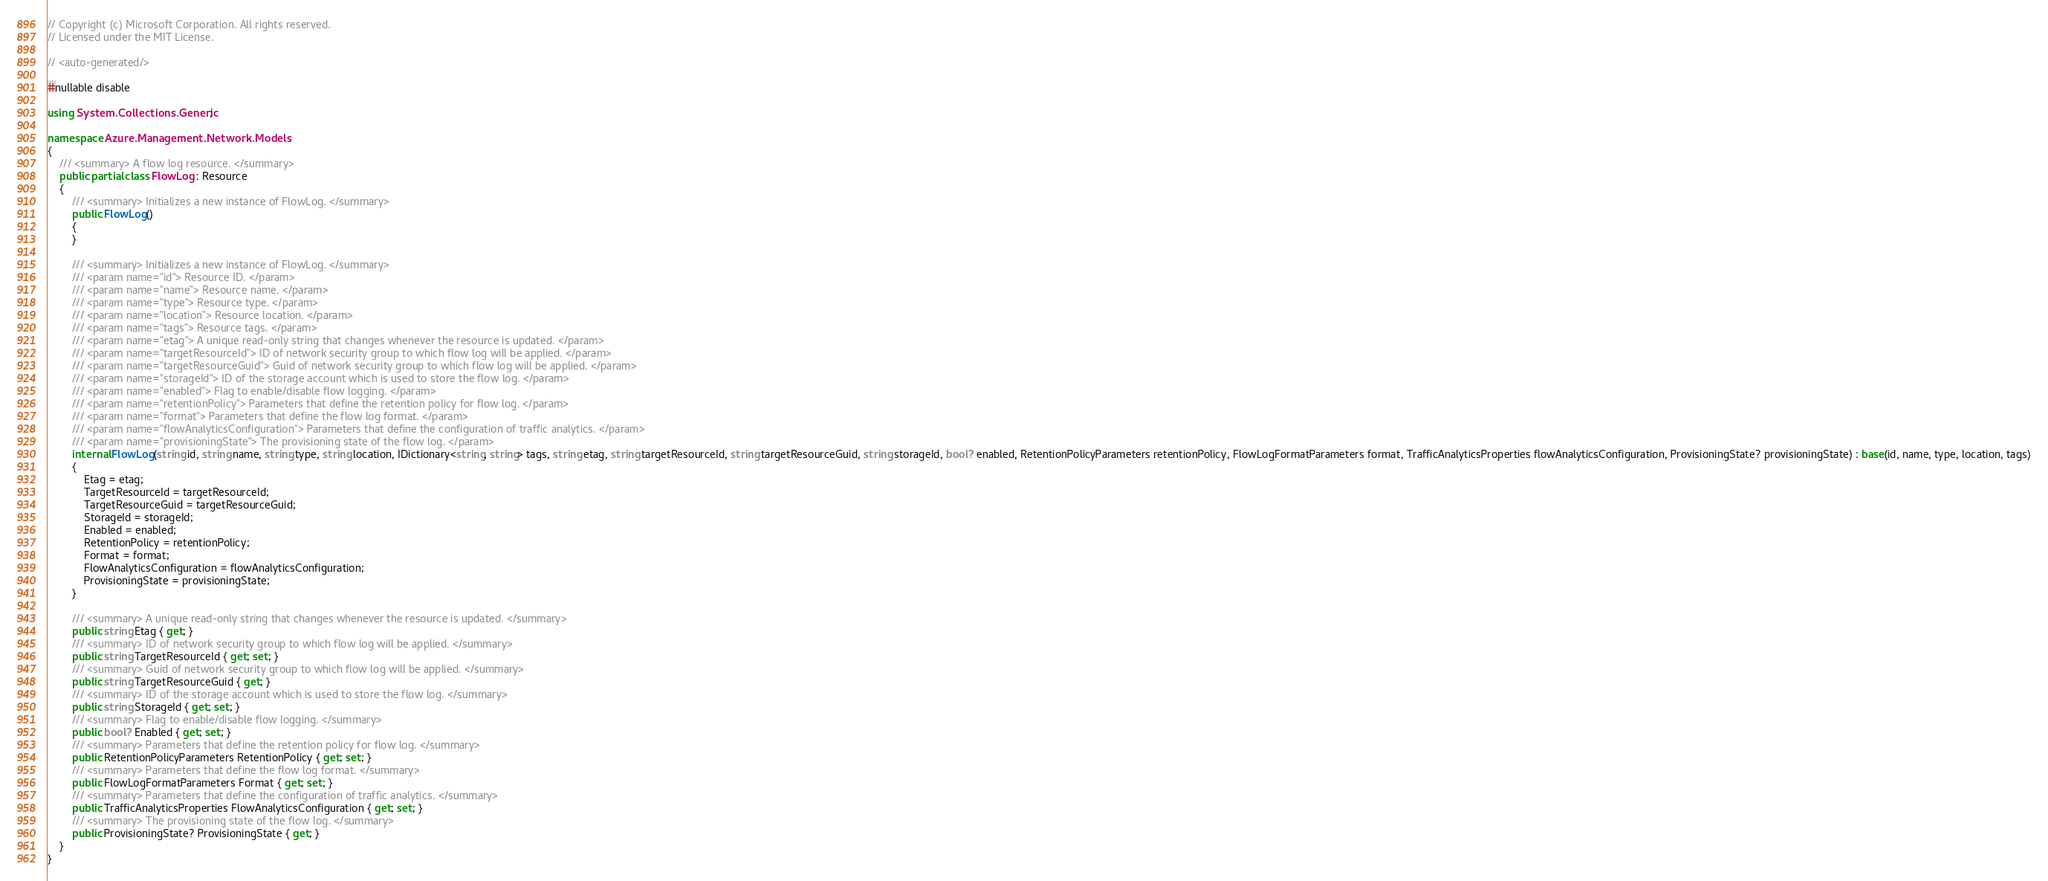Convert code to text. <code><loc_0><loc_0><loc_500><loc_500><_C#_>// Copyright (c) Microsoft Corporation. All rights reserved.
// Licensed under the MIT License.

// <auto-generated/>

#nullable disable

using System.Collections.Generic;

namespace Azure.Management.Network.Models
{
    /// <summary> A flow log resource. </summary>
    public partial class FlowLog : Resource
    {
        /// <summary> Initializes a new instance of FlowLog. </summary>
        public FlowLog()
        {
        }

        /// <summary> Initializes a new instance of FlowLog. </summary>
        /// <param name="id"> Resource ID. </param>
        /// <param name="name"> Resource name. </param>
        /// <param name="type"> Resource type. </param>
        /// <param name="location"> Resource location. </param>
        /// <param name="tags"> Resource tags. </param>
        /// <param name="etag"> A unique read-only string that changes whenever the resource is updated. </param>
        /// <param name="targetResourceId"> ID of network security group to which flow log will be applied. </param>
        /// <param name="targetResourceGuid"> Guid of network security group to which flow log will be applied. </param>
        /// <param name="storageId"> ID of the storage account which is used to store the flow log. </param>
        /// <param name="enabled"> Flag to enable/disable flow logging. </param>
        /// <param name="retentionPolicy"> Parameters that define the retention policy for flow log. </param>
        /// <param name="format"> Parameters that define the flow log format. </param>
        /// <param name="flowAnalyticsConfiguration"> Parameters that define the configuration of traffic analytics. </param>
        /// <param name="provisioningState"> The provisioning state of the flow log. </param>
        internal FlowLog(string id, string name, string type, string location, IDictionary<string, string> tags, string etag, string targetResourceId, string targetResourceGuid, string storageId, bool? enabled, RetentionPolicyParameters retentionPolicy, FlowLogFormatParameters format, TrafficAnalyticsProperties flowAnalyticsConfiguration, ProvisioningState? provisioningState) : base(id, name, type, location, tags)
        {
            Etag = etag;
            TargetResourceId = targetResourceId;
            TargetResourceGuid = targetResourceGuid;
            StorageId = storageId;
            Enabled = enabled;
            RetentionPolicy = retentionPolicy;
            Format = format;
            FlowAnalyticsConfiguration = flowAnalyticsConfiguration;
            ProvisioningState = provisioningState;
        }

        /// <summary> A unique read-only string that changes whenever the resource is updated. </summary>
        public string Etag { get; }
        /// <summary> ID of network security group to which flow log will be applied. </summary>
        public string TargetResourceId { get; set; }
        /// <summary> Guid of network security group to which flow log will be applied. </summary>
        public string TargetResourceGuid { get; }
        /// <summary> ID of the storage account which is used to store the flow log. </summary>
        public string StorageId { get; set; }
        /// <summary> Flag to enable/disable flow logging. </summary>
        public bool? Enabled { get; set; }
        /// <summary> Parameters that define the retention policy for flow log. </summary>
        public RetentionPolicyParameters RetentionPolicy { get; set; }
        /// <summary> Parameters that define the flow log format. </summary>
        public FlowLogFormatParameters Format { get; set; }
        /// <summary> Parameters that define the configuration of traffic analytics. </summary>
        public TrafficAnalyticsProperties FlowAnalyticsConfiguration { get; set; }
        /// <summary> The provisioning state of the flow log. </summary>
        public ProvisioningState? ProvisioningState { get; }
    }
}
</code> 